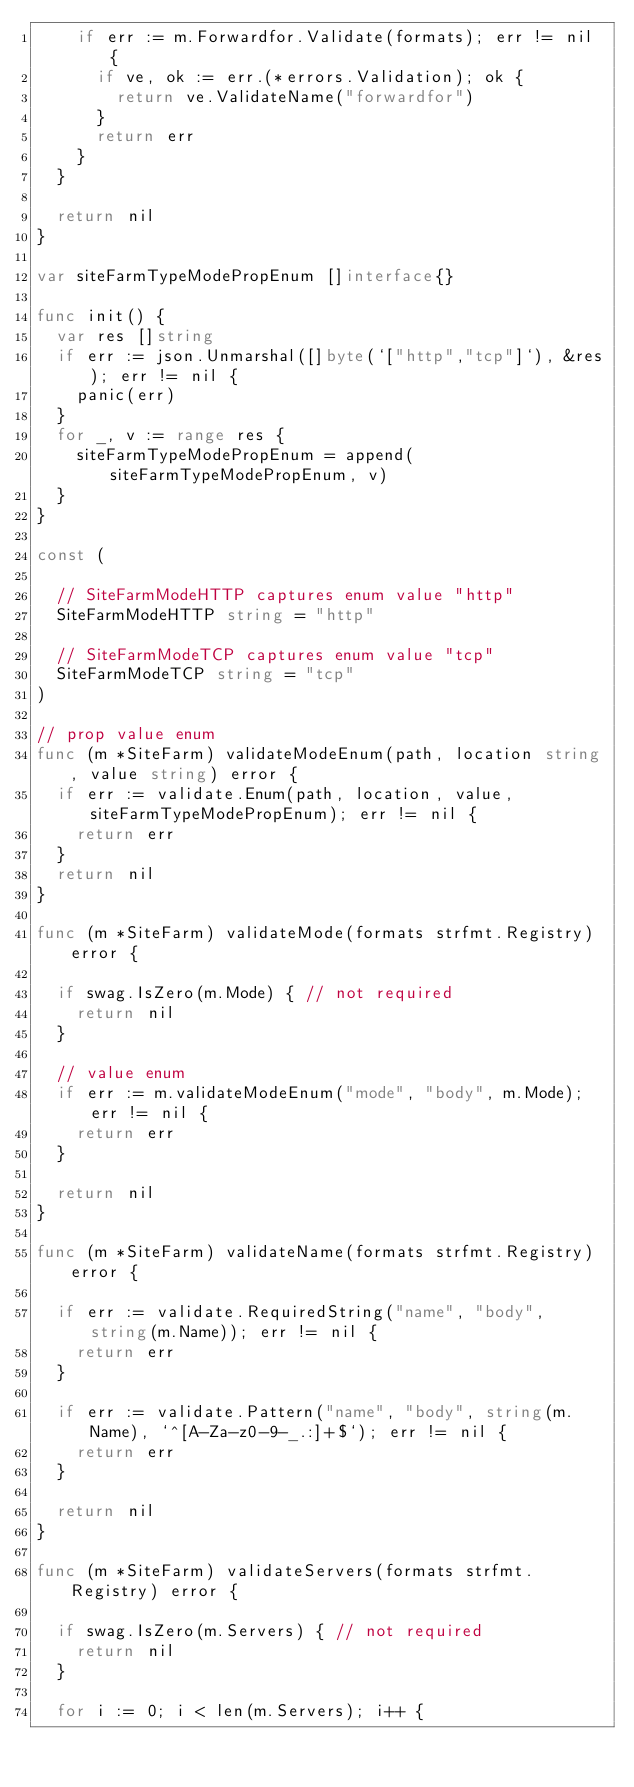<code> <loc_0><loc_0><loc_500><loc_500><_Go_>		if err := m.Forwardfor.Validate(formats); err != nil {
			if ve, ok := err.(*errors.Validation); ok {
				return ve.ValidateName("forwardfor")
			}
			return err
		}
	}

	return nil
}

var siteFarmTypeModePropEnum []interface{}

func init() {
	var res []string
	if err := json.Unmarshal([]byte(`["http","tcp"]`), &res); err != nil {
		panic(err)
	}
	for _, v := range res {
		siteFarmTypeModePropEnum = append(siteFarmTypeModePropEnum, v)
	}
}

const (

	// SiteFarmModeHTTP captures enum value "http"
	SiteFarmModeHTTP string = "http"

	// SiteFarmModeTCP captures enum value "tcp"
	SiteFarmModeTCP string = "tcp"
)

// prop value enum
func (m *SiteFarm) validateModeEnum(path, location string, value string) error {
	if err := validate.Enum(path, location, value, siteFarmTypeModePropEnum); err != nil {
		return err
	}
	return nil
}

func (m *SiteFarm) validateMode(formats strfmt.Registry) error {

	if swag.IsZero(m.Mode) { // not required
		return nil
	}

	// value enum
	if err := m.validateModeEnum("mode", "body", m.Mode); err != nil {
		return err
	}

	return nil
}

func (m *SiteFarm) validateName(formats strfmt.Registry) error {

	if err := validate.RequiredString("name", "body", string(m.Name)); err != nil {
		return err
	}

	if err := validate.Pattern("name", "body", string(m.Name), `^[A-Za-z0-9-_.:]+$`); err != nil {
		return err
	}

	return nil
}

func (m *SiteFarm) validateServers(formats strfmt.Registry) error {

	if swag.IsZero(m.Servers) { // not required
		return nil
	}

	for i := 0; i < len(m.Servers); i++ {</code> 